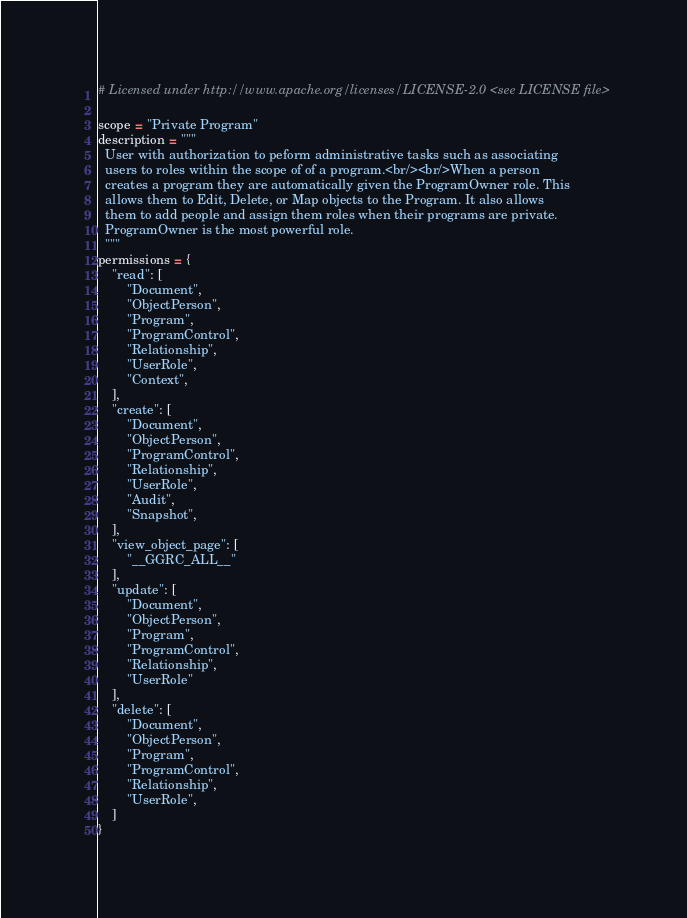Convert code to text. <code><loc_0><loc_0><loc_500><loc_500><_Python_># Licensed under http://www.apache.org/licenses/LICENSE-2.0 <see LICENSE file>

scope = "Private Program"
description = """
  User with authorization to peform administrative tasks such as associating
  users to roles within the scope of of a program.<br/><br/>When a person
  creates a program they are automatically given the ProgramOwner role. This
  allows them to Edit, Delete, or Map objects to the Program. It also allows
  them to add people and assign them roles when their programs are private.
  ProgramOwner is the most powerful role.
  """
permissions = {
    "read": [
        "Document",
        "ObjectPerson",
        "Program",
        "ProgramControl",
        "Relationship",
        "UserRole",
        "Context",
    ],
    "create": [
        "Document",
        "ObjectPerson",
        "ProgramControl",
        "Relationship",
        "UserRole",
        "Audit",
        "Snapshot",
    ],
    "view_object_page": [
        "__GGRC_ALL__"
    ],
    "update": [
        "Document",
        "ObjectPerson",
        "Program",
        "ProgramControl",
        "Relationship",
        "UserRole"
    ],
    "delete": [
        "Document",
        "ObjectPerson",
        "Program",
        "ProgramControl",
        "Relationship",
        "UserRole",
    ]
}
</code> 